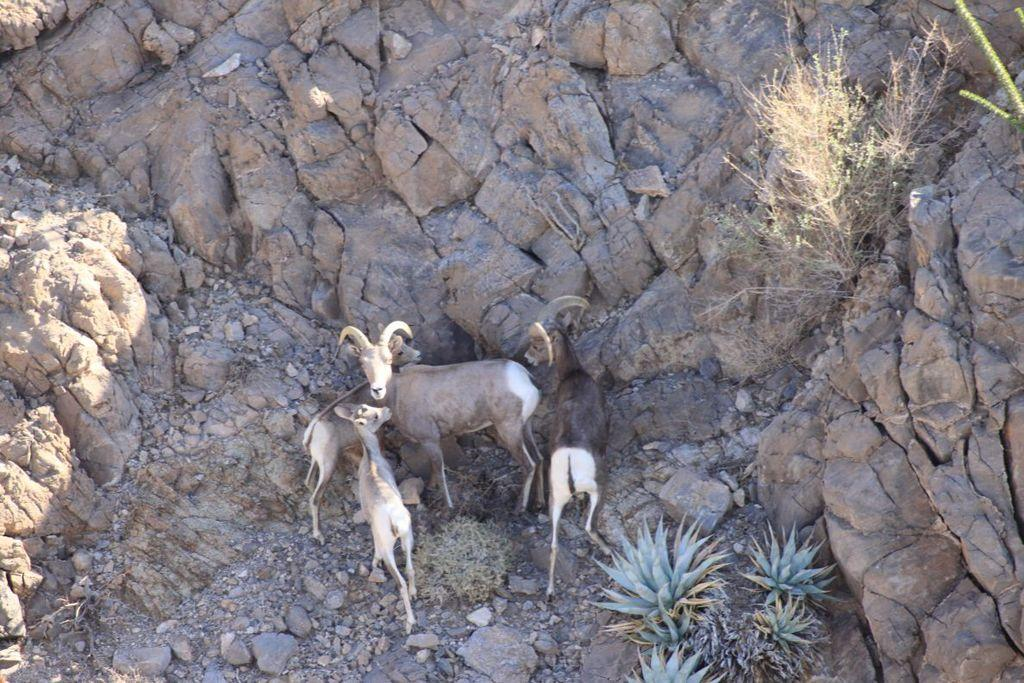What type of living organisms are present in the image? There are animals standing on the ground in the image. What type of natural elements can be seen in the image? There are stones, plants, and rocks visible in the image. What type of owl can be seen perched on the sidewalk in the image? There is no owl or sidewalk present in the image. What reason might the animals have for standing on the ground in the image? The image does not provide any information about the reason for the animals' actions. 